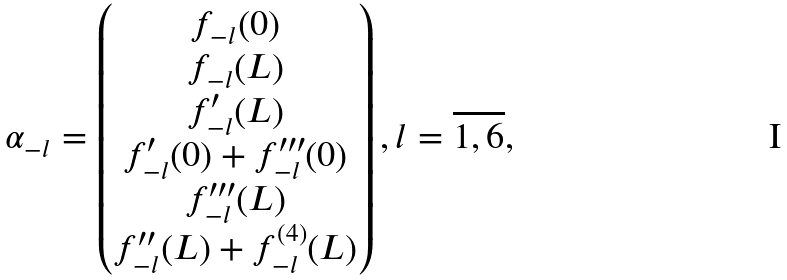Convert formula to latex. <formula><loc_0><loc_0><loc_500><loc_500>\alpha _ { - l } = \begin{pmatrix} f _ { - l } ( 0 ) \\ f _ { - l } ( L ) \\ f _ { - l } ^ { \prime } ( L ) \\ f _ { - l } ^ { \prime } ( 0 ) + f _ { - l } ^ { \prime \prime \prime } ( 0 ) \\ f _ { - l } ^ { \prime \prime \prime } ( L ) \\ f _ { - l } ^ { \prime \prime } ( L ) + f _ { - l } ^ { ( 4 ) } ( L ) \end{pmatrix} , l = \overline { 1 , 6 } ,</formula> 